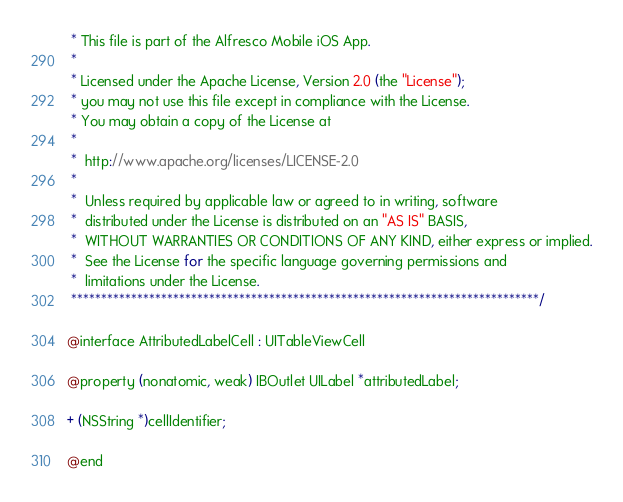<code> <loc_0><loc_0><loc_500><loc_500><_C_> * This file is part of the Alfresco Mobile iOS App.
 * 
 * Licensed under the Apache License, Version 2.0 (the "License");
 * you may not use this file except in compliance with the License.
 * You may obtain a copy of the License at
 *  
 *  http://www.apache.org/licenses/LICENSE-2.0
 * 
 *  Unless required by applicable law or agreed to in writing, software
 *  distributed under the License is distributed on an "AS IS" BASIS,
 *  WITHOUT WARRANTIES OR CONDITIONS OF ANY KIND, either express or implied.
 *  See the License for the specific language governing permissions and
 *  limitations under the License.
 ******************************************************************************/
  
@interface AttributedLabelCell : UITableViewCell

@property (nonatomic, weak) IBOutlet UILabel *attributedLabel;

+ (NSString *)cellIdentifier;

@end
</code> 